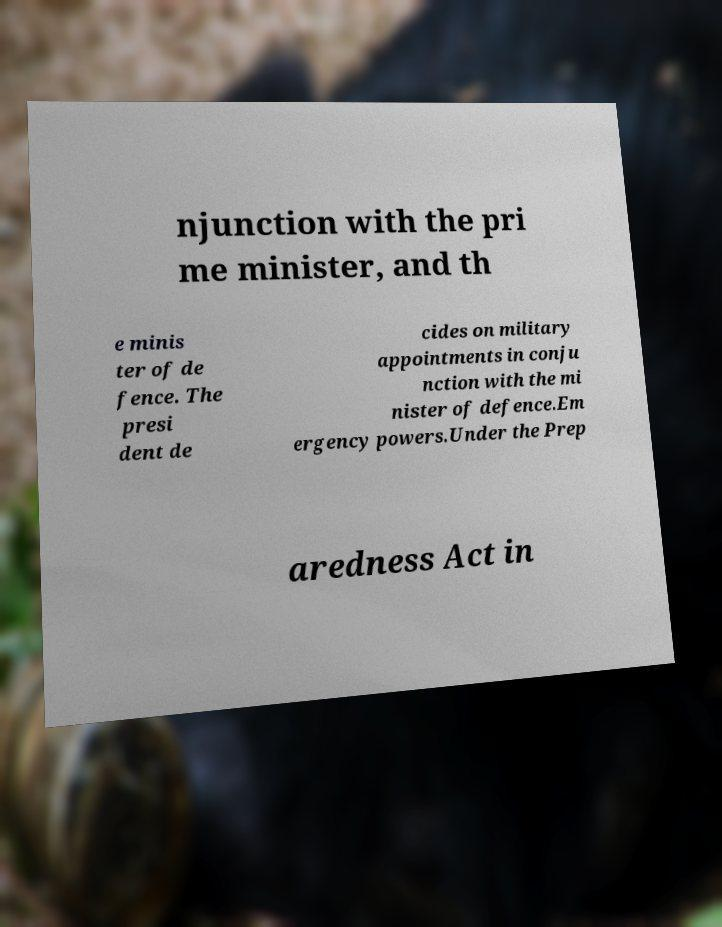Can you accurately transcribe the text from the provided image for me? njunction with the pri me minister, and th e minis ter of de fence. The presi dent de cides on military appointments in conju nction with the mi nister of defence.Em ergency powers.Under the Prep aredness Act in 